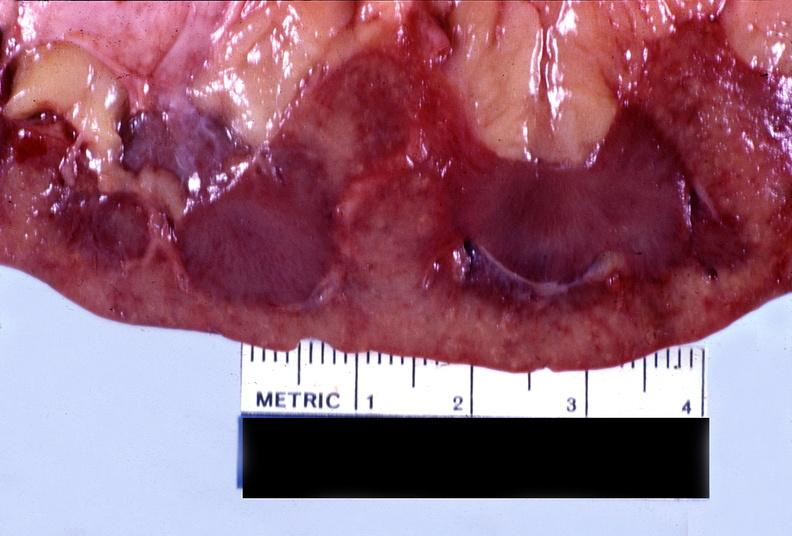what does this image show?
Answer the question using a single word or phrase. Kidney 